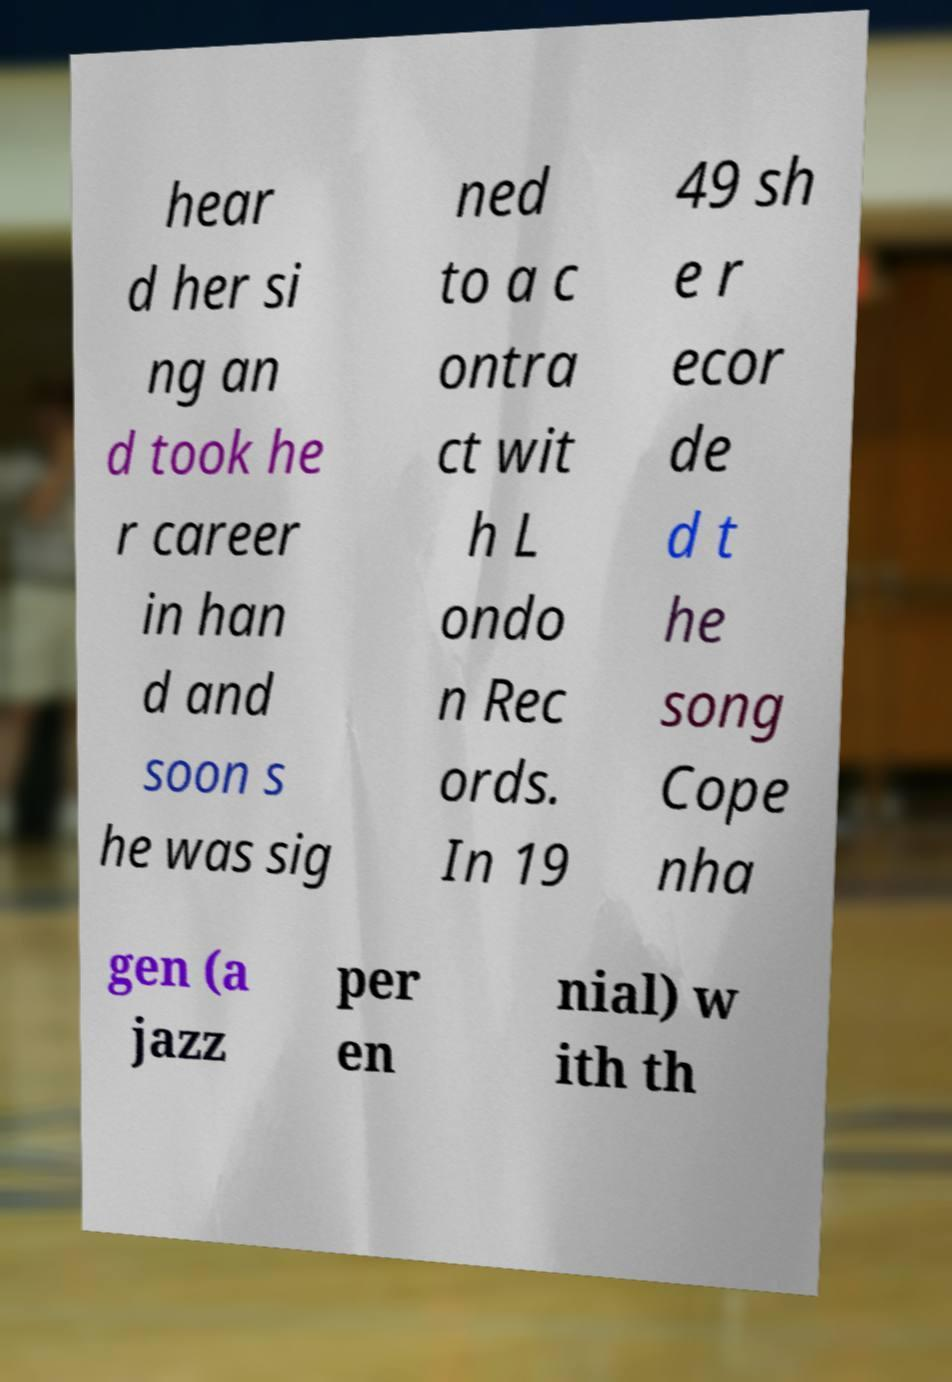I need the written content from this picture converted into text. Can you do that? hear d her si ng an d took he r career in han d and soon s he was sig ned to a c ontra ct wit h L ondo n Rec ords. In 19 49 sh e r ecor de d t he song Cope nha gen (a jazz per en nial) w ith th 